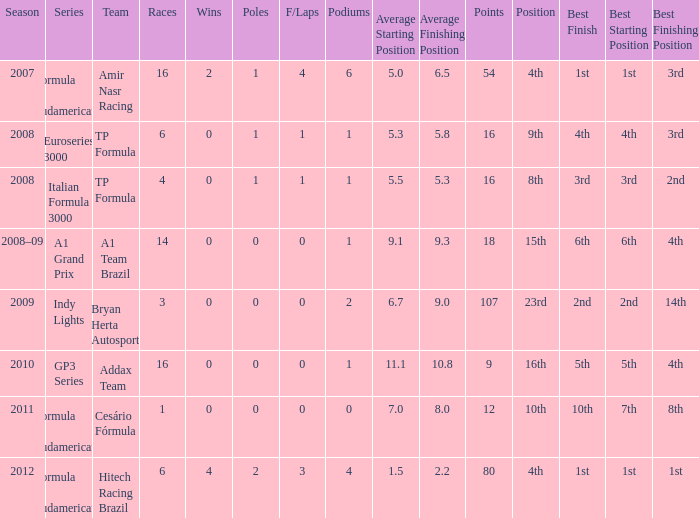Could you parse the entire table as a dict? {'header': ['Season', 'Series', 'Team', 'Races', 'Wins', 'Poles', 'F/Laps', 'Podiums', 'Average Starting Position', 'Average Finishing Position', 'Points', 'Position', 'Best Finish', 'Best Starting Position', 'Best Finishing Position'], 'rows': [['2007', 'Formula 3 Sudamericana', 'Amir Nasr Racing', '16', '2', '1', '4', '6', '5.0', '6.5', '54', '4th', '1st', '1st', '3rd'], ['2008', 'Euroseries 3000', 'TP Formula', '6', '0', '1', '1', '1', '5.3', '5.8', '16', '9th', '4th', '4th', '3rd'], ['2008', 'Italian Formula 3000', 'TP Formula', '4', '0', '1', '1', '1', '5.5', '5.3', '16', '8th', '3rd', '3rd', '2nd'], ['2008–09', 'A1 Grand Prix', 'A1 Team Brazil', '14', '0', '0', '0', '1', '9.1', '9.3', '18', '15th', '6th', '6th', '4th'], ['2009', 'Indy Lights', 'Bryan Herta Autosport', '3', '0', '0', '0', '2', '6.7', '9.0', '107', '23rd', '2nd', '2nd', '14th'], ['2010', 'GP3 Series', 'Addax Team', '16', '0', '0', '0', '1', '11.1', '10.8', '9', '16th', '5th', '5th', '4th'], ['2011', 'Formula 3 Sudamericana', 'Cesário Fórmula', '1', '0', '0', '0', '0', '7.0', '8.0', '12', '10th', '10th', '7th', '8th'], ['2012', 'Formula 3 Sudamericana', 'Hitech Racing Brazil', '6', '4', '2', '3', '4', '1.5', '2.2', '80', '4th', '1st', '1st', '1st']]} For which team did he compete in the gp3 series? Addax Team. 